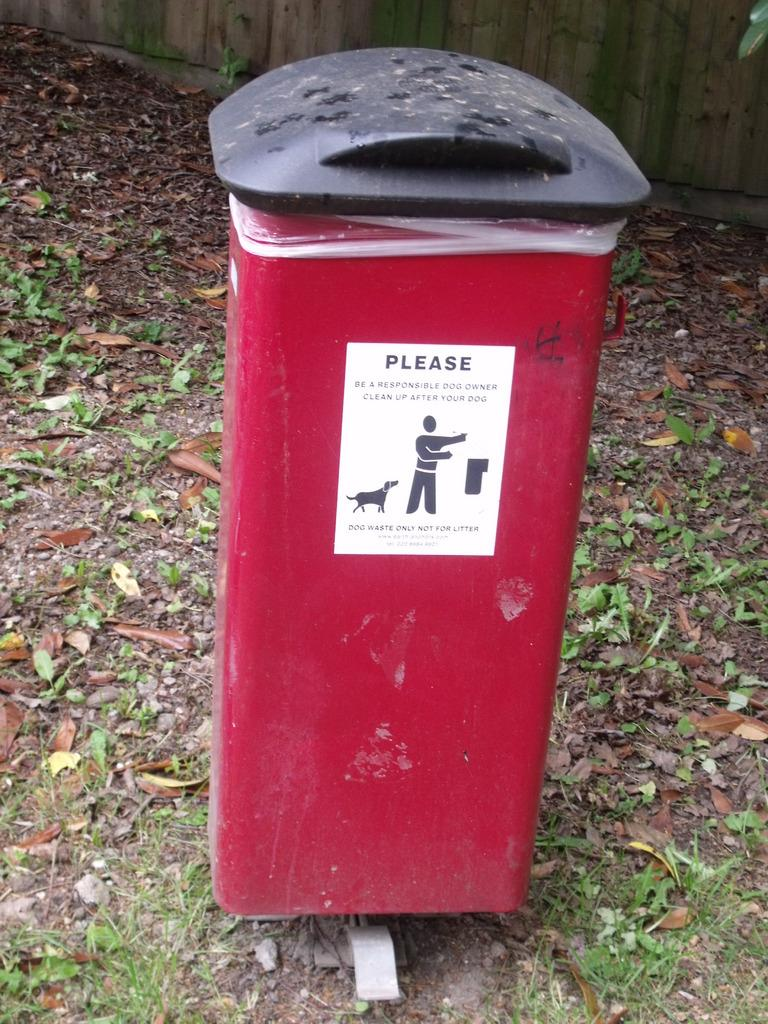<image>
Offer a succinct explanation of the picture presented. the red trash can asks people to clean up after their pets 